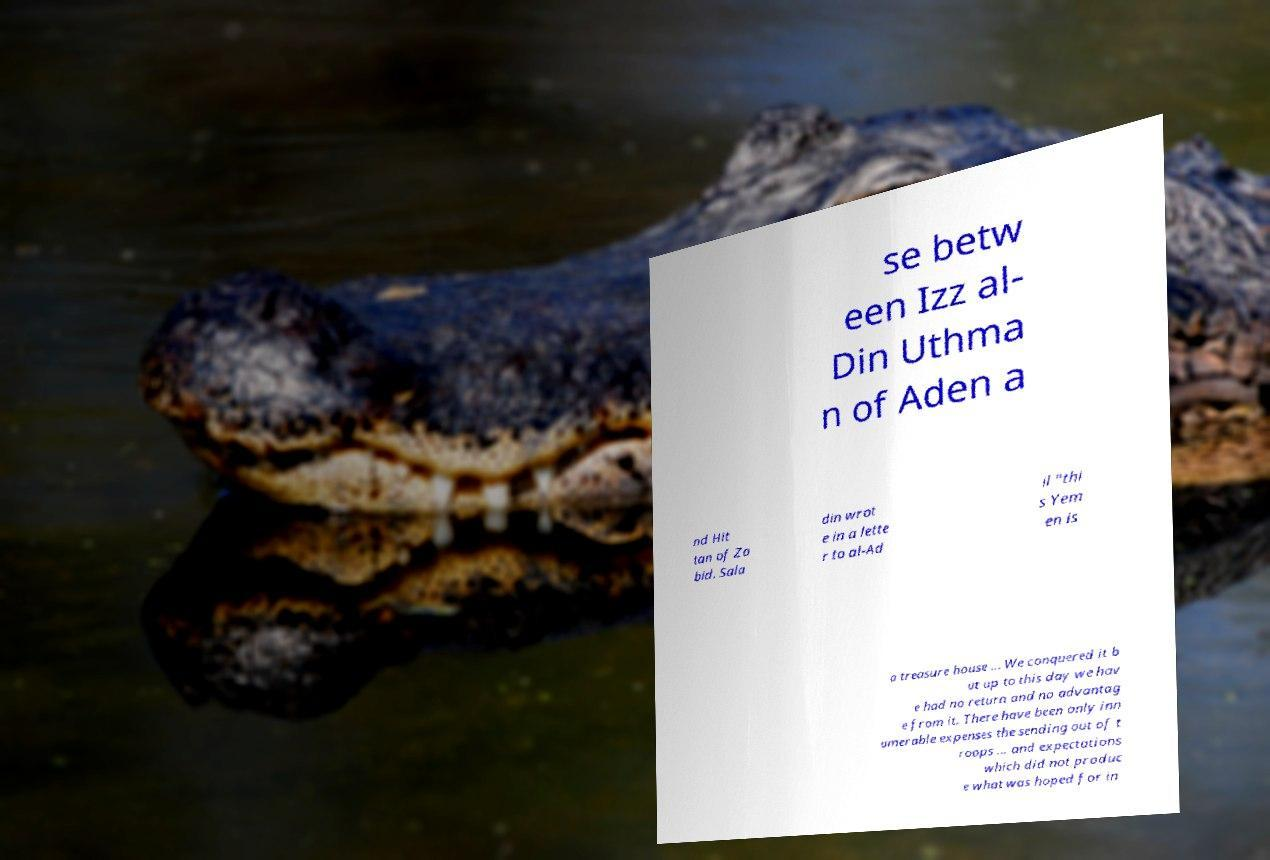What messages or text are displayed in this image? I need them in a readable, typed format. se betw een Izz al- Din Uthma n of Aden a nd Hit tan of Za bid. Sala din wrot e in a lette r to al-Ad il "thi s Yem en is a treasure house ... We conquered it b ut up to this day we hav e had no return and no advantag e from it. There have been only inn umerable expenses the sending out of t roops ... and expectations which did not produc e what was hoped for in 